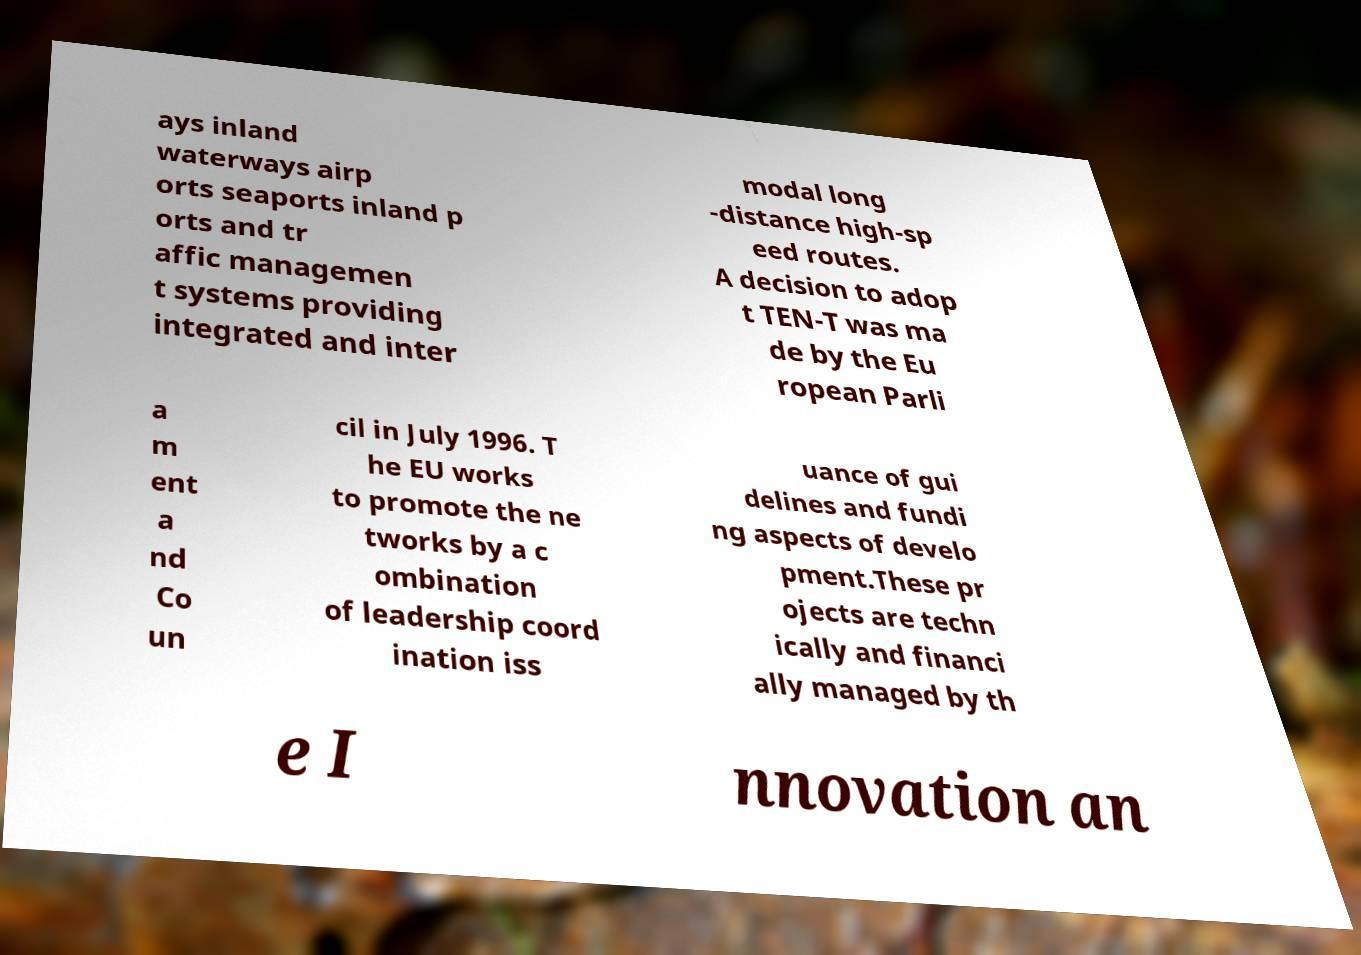For documentation purposes, I need the text within this image transcribed. Could you provide that? ays inland waterways airp orts seaports inland p orts and tr affic managemen t systems providing integrated and inter modal long -distance high-sp eed routes. A decision to adop t TEN-T was ma de by the Eu ropean Parli a m ent a nd Co un cil in July 1996. T he EU works to promote the ne tworks by a c ombination of leadership coord ination iss uance of gui delines and fundi ng aspects of develo pment.These pr ojects are techn ically and financi ally managed by th e I nnovation an 